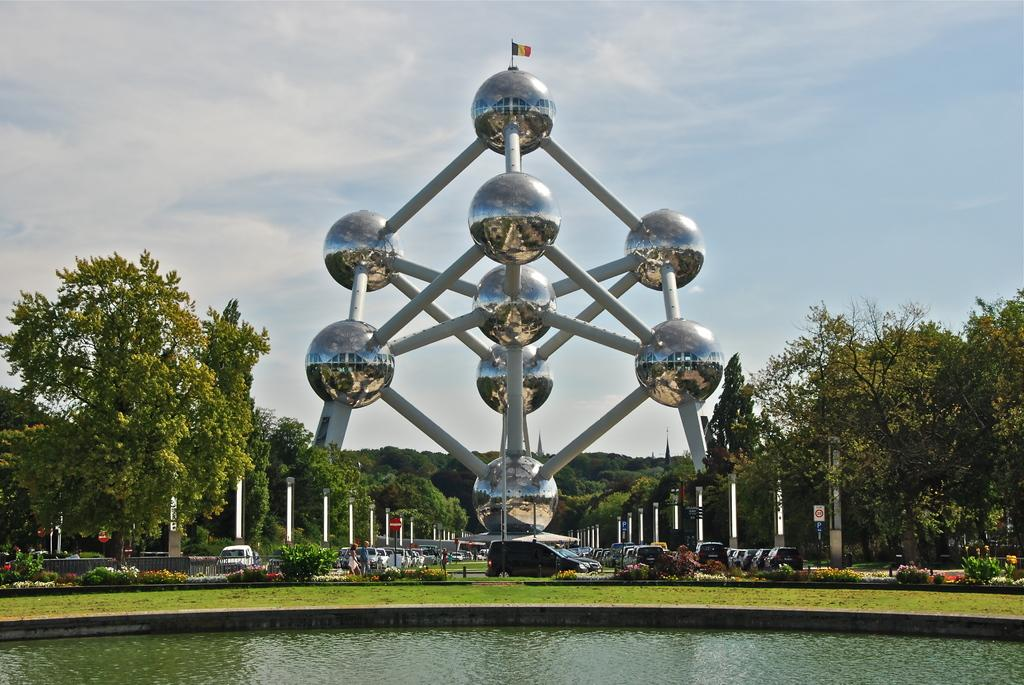What type of natural elements can be seen in the image? There are trees in the image. What man-made objects are present in the image? There are vehicles in the image. What can be seen in the background of the image? There is water and sky visible in the image. How many frogs are jumping in the water in the image? There are no frogs present in the image; it features trees, vehicles, water, and sky. What type of shock can be seen in the image? There is no shock present in the image. 